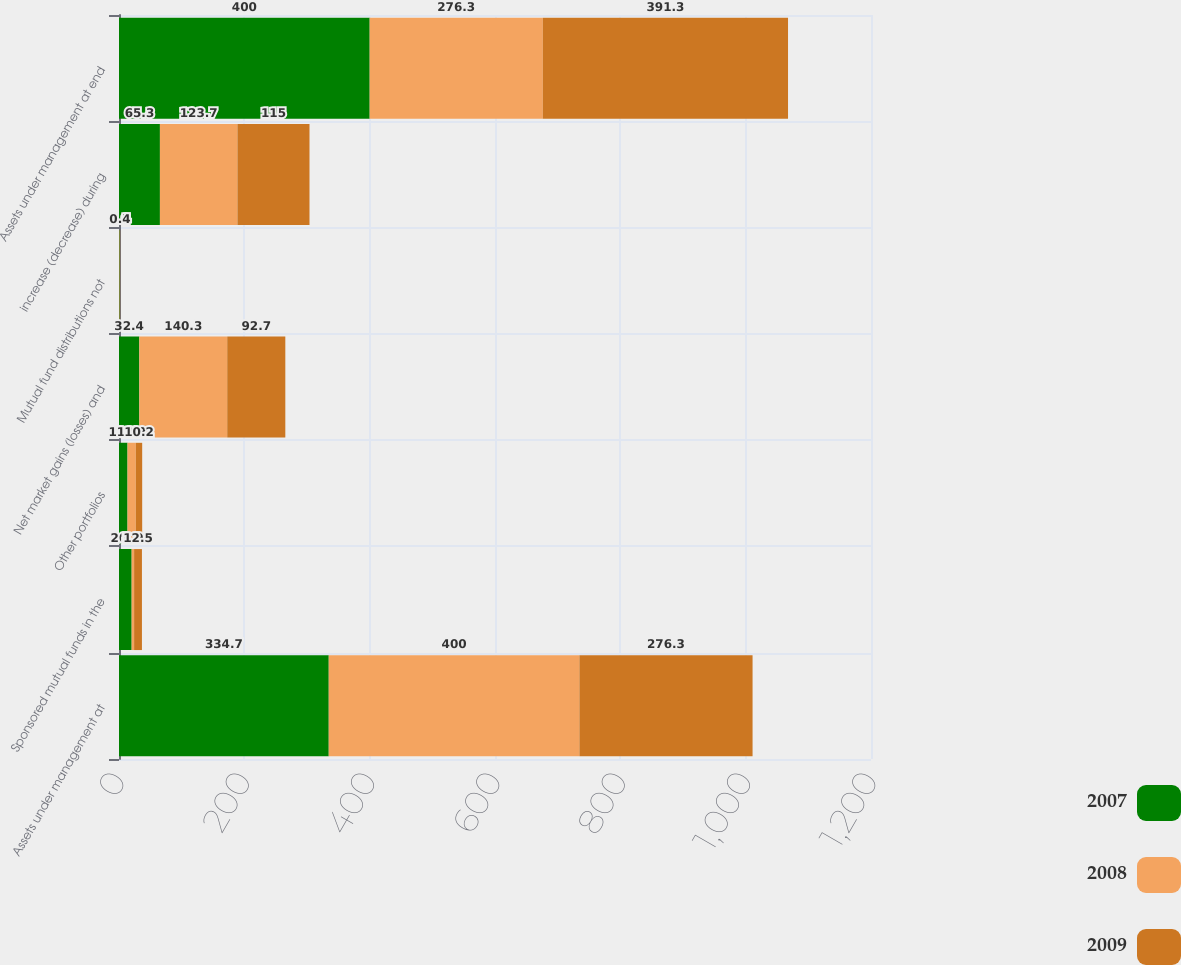Convert chart to OTSL. <chart><loc_0><loc_0><loc_500><loc_500><stacked_bar_chart><ecel><fcel>Assets under management at<fcel>Sponsored mutual funds in the<fcel>Other portfolios<fcel>Net market gains (losses) and<fcel>Mutual fund distributions not<fcel>increase (decrease) during<fcel>Assets under management at end<nl><fcel>2007<fcel>334.7<fcel>20.2<fcel>13.6<fcel>32.4<fcel>0.9<fcel>65.3<fcel>400<nl><fcel>2008<fcel>400<fcel>3.9<fcel>13.2<fcel>140.3<fcel>0.5<fcel>123.7<fcel>276.3<nl><fcel>2009<fcel>276.3<fcel>12.5<fcel>10.2<fcel>92.7<fcel>0.4<fcel>115<fcel>391.3<nl></chart> 